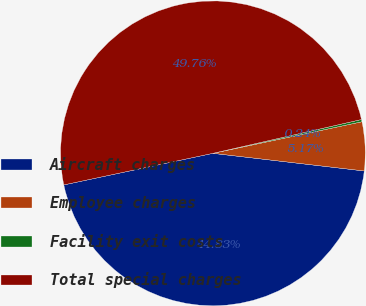Convert chart to OTSL. <chart><loc_0><loc_0><loc_500><loc_500><pie_chart><fcel>Aircraft charges<fcel>Employee charges<fcel>Facility exit costs<fcel>Total special charges<nl><fcel>44.83%<fcel>5.17%<fcel>0.24%<fcel>49.76%<nl></chart> 